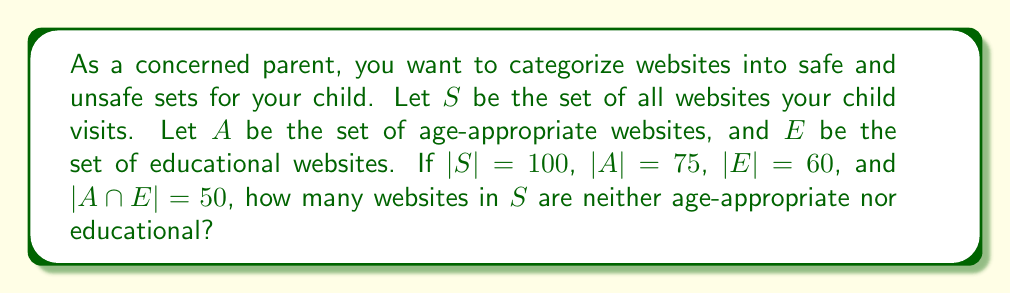Provide a solution to this math problem. To solve this problem, we'll use set theory concepts:

1) First, let's identify what we're looking for: websites that are neither age-appropriate nor educational. This is the complement of the union of $A$ and $E$ within $S$.

2) We can express this as: $|S - (A \cup E)|$

3) To find this, we can use the formula:
   $|S - (A \cup E)| = |S| - |A \cup E|$

4) To find $|A \cup E|$, we can use the inclusion-exclusion principle:
   $|A \cup E| = |A| + |E| - |A \cap E|$

5) We know:
   $|S| = 100$
   $|A| = 75$
   $|E| = 60$
   $|A \cap E| = 50$

6) Let's calculate $|A \cup E|$:
   $|A \cup E| = 75 + 60 - 50 = 85$

7) Now we can calculate $|S - (A \cup E)|$:
   $|S - (A \cup E)| = |S| - |A \cup E| = 100 - 85 = 15$

Therefore, 15 websites are neither age-appropriate nor educational.
Answer: 15 websites 